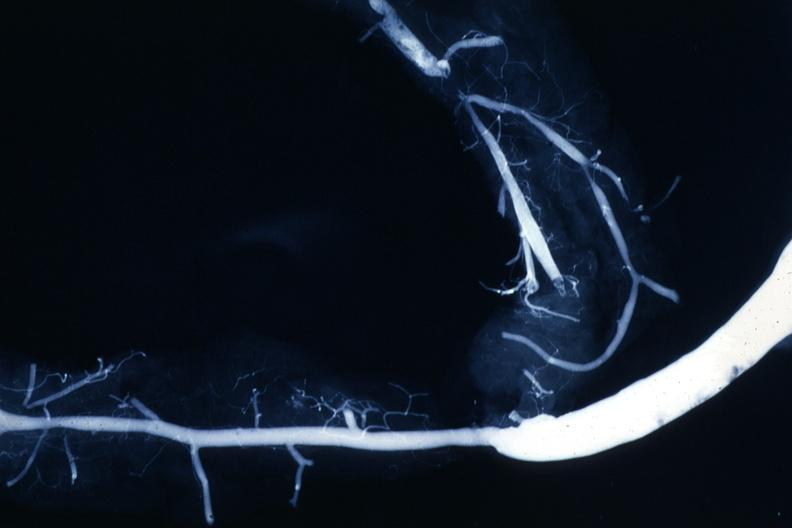s angiogram saphenous vein bypass graft present?
Answer the question using a single word or phrase. Yes 